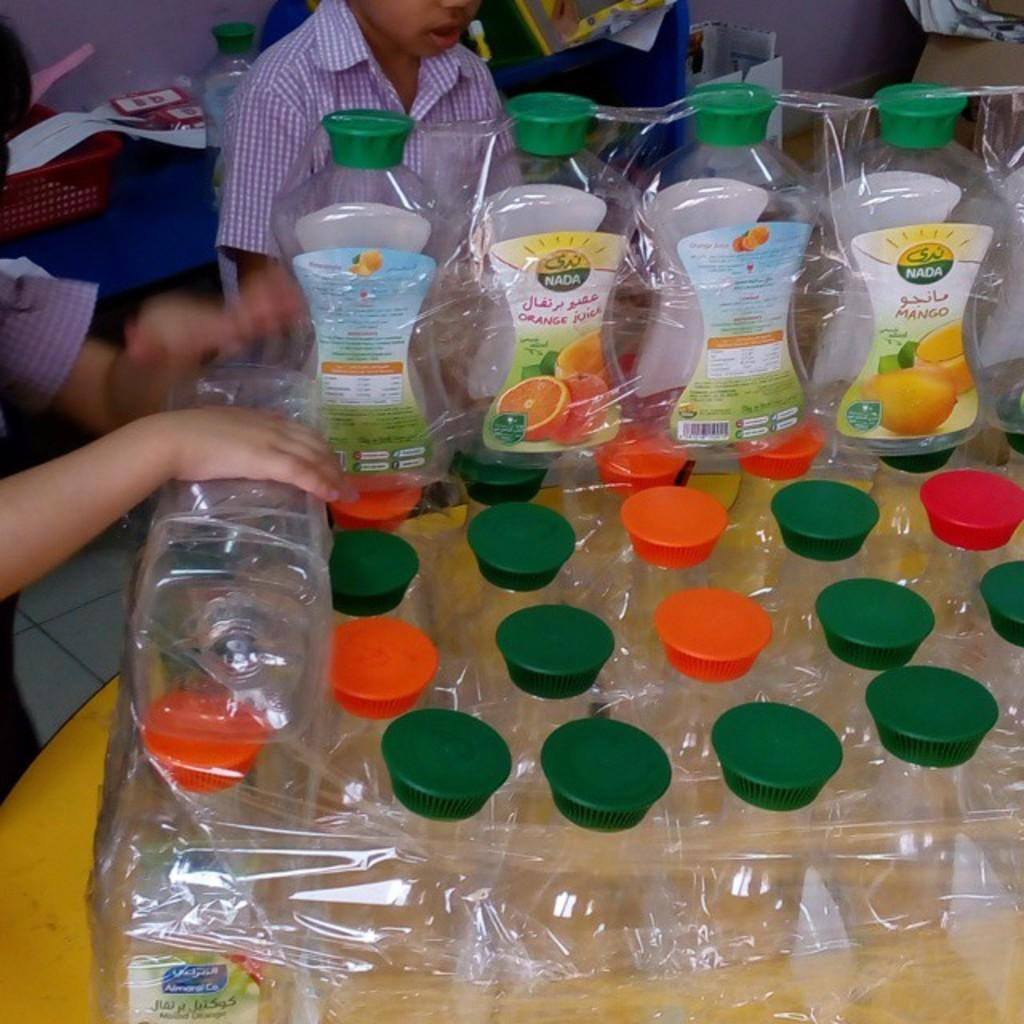<image>
Write a terse but informative summary of the picture. Empty bottles of NADA brand fruit juice are wrapped together. 